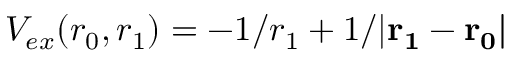<formula> <loc_0><loc_0><loc_500><loc_500>V _ { e x } ( r _ { 0 } , r _ { 1 } ) = - 1 / r _ { 1 } + 1 / { | r _ { 1 } - r _ { 0 } | }</formula> 